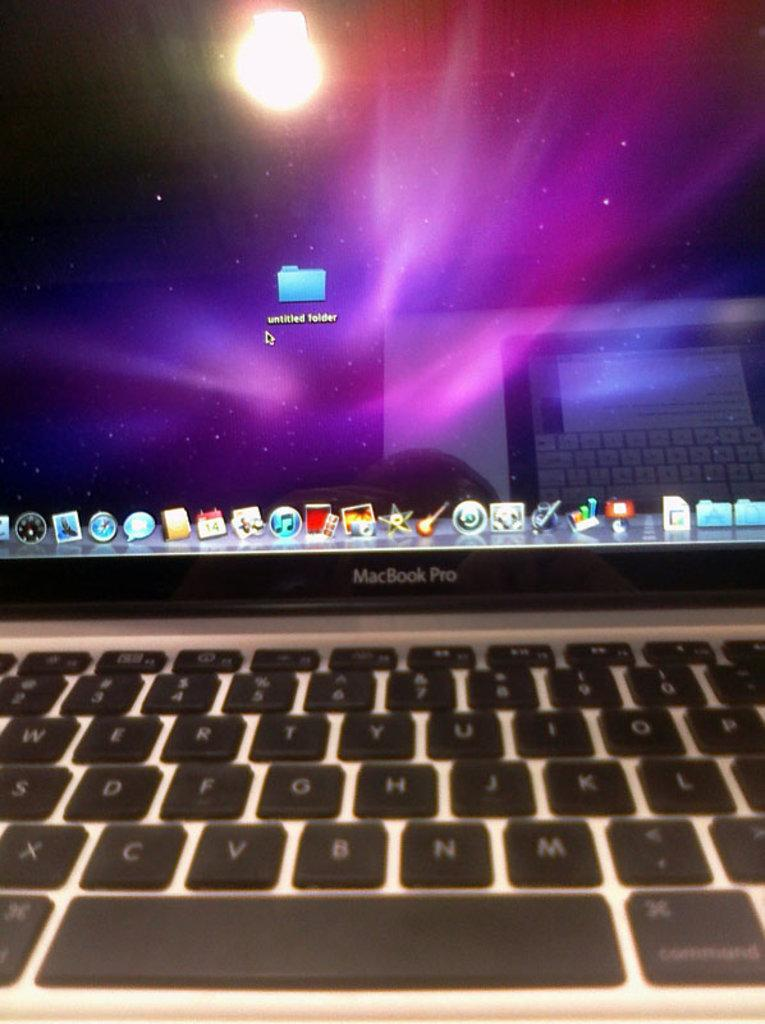Provide a one-sentence caption for the provided image. A MacBook Pro with an untitled folder in next to the mouse arrow. 